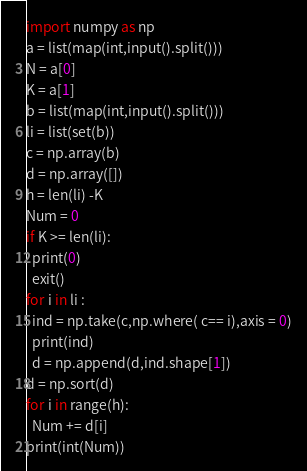<code> <loc_0><loc_0><loc_500><loc_500><_Python_>import numpy as np
a = list(map(int,input().split()))
N = a[0]
K = a[1]
b = list(map(int,input().split()))
li = list(set(b))
c = np.array(b)
d = np.array([])
h = len(li) -K
Num = 0
if K >= len(li):
  print(0)
  exit()
for i in li :
  ind = np.take(c,np.where( c== i),axis = 0)
  print(ind)
  d = np.append(d,ind.shape[1])
d = np.sort(d)
for i in range(h):
  Num += d[i]
print(int(Num))</code> 